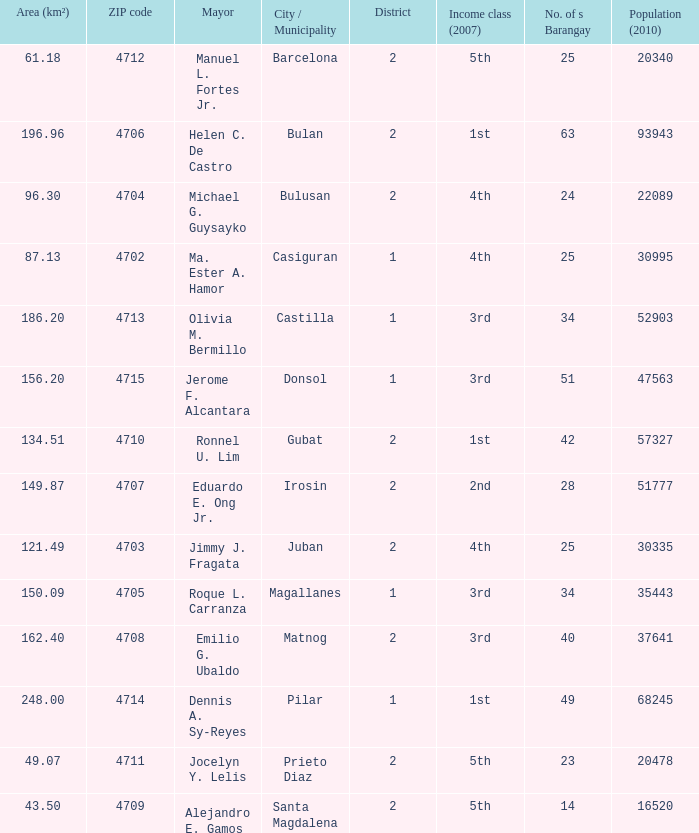What are all the profits elegance (2007) in which mayor is ma. Ester a. Hamor 4th. 